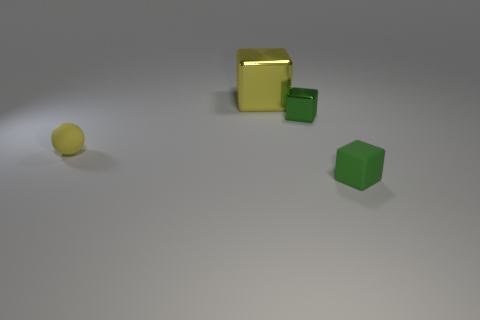Add 4 tiny yellow matte spheres. How many objects exist? 8 Subtract all tiny blocks. How many blocks are left? 1 Subtract all green blocks. How many blocks are left? 1 Subtract all blocks. How many objects are left? 1 Subtract 3 blocks. How many blocks are left? 0 Add 2 small rubber spheres. How many small rubber spheres are left? 3 Add 4 blocks. How many blocks exist? 7 Subtract 0 gray spheres. How many objects are left? 4 Subtract all brown blocks. Subtract all purple cylinders. How many blocks are left? 3 Subtract all yellow blocks. How many brown spheres are left? 0 